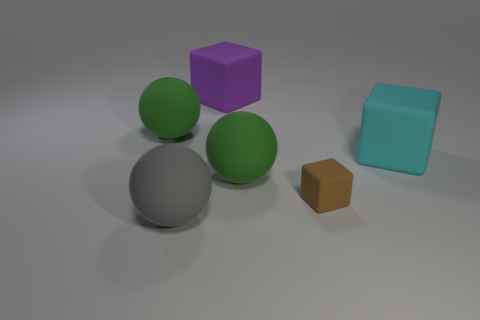There is a big sphere that is to the left of the large gray sphere; what color is it?
Your answer should be compact. Green. There is a brown thing that is the same material as the cyan block; what is its size?
Offer a very short reply. Small. There is another purple thing that is the same shape as the tiny rubber object; what is its size?
Your answer should be very brief. Large. Is there a large cyan rubber block?
Offer a very short reply. Yes. How many things are either big cubes behind the tiny rubber block or cyan cubes?
Offer a very short reply. 2. What is the color of the rubber sphere in front of the green matte sphere on the right side of the big purple matte thing?
Your answer should be compact. Gray. There is a small matte cube; what number of large gray things are on the right side of it?
Offer a terse response. 0. The tiny matte thing is what color?
Your answer should be very brief. Brown. How many big things are cyan matte cubes or purple things?
Offer a terse response. 2. Is the color of the rubber ball that is behind the cyan cube the same as the sphere right of the large gray sphere?
Your response must be concise. Yes. 